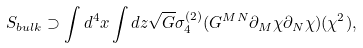Convert formula to latex. <formula><loc_0><loc_0><loc_500><loc_500>S _ { b u l k } \supset \int d ^ { 4 } x \int d z \sqrt { G } \sigma _ { 4 } ^ { ( 2 ) } ( G ^ { M N } \partial _ { M } \chi \partial _ { N } \chi ) ( \chi ^ { 2 } ) ,</formula> 